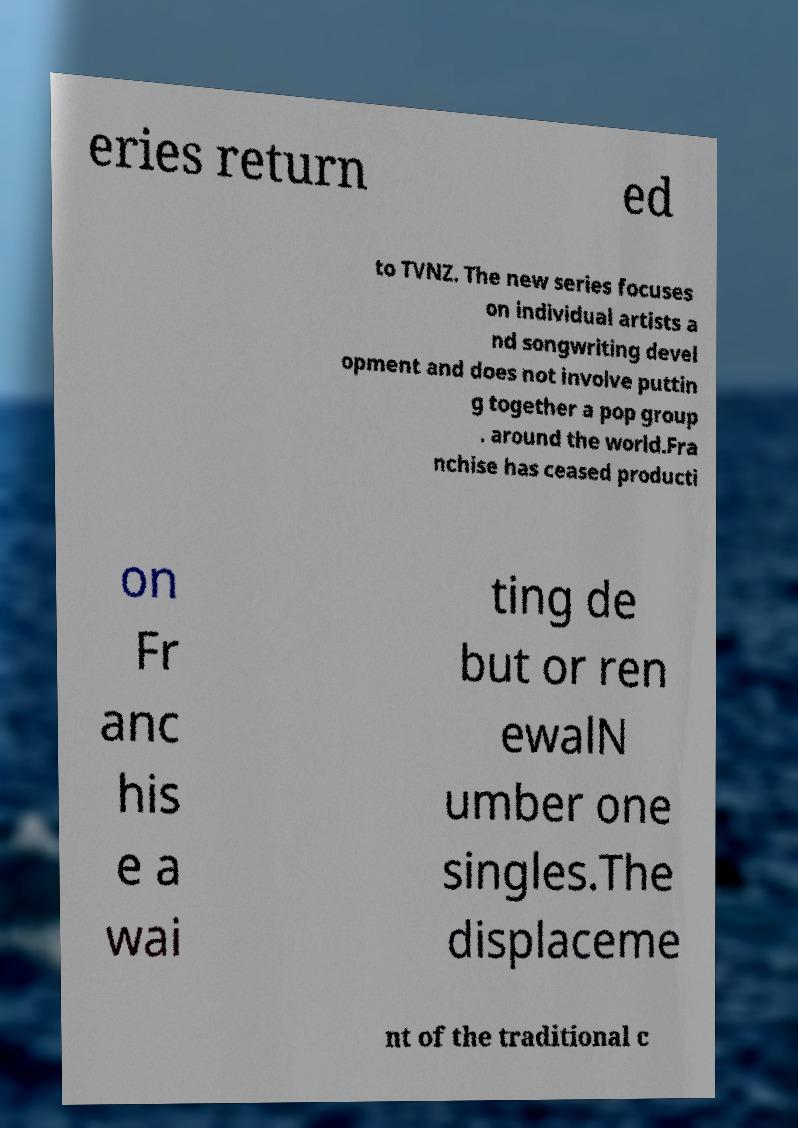Please identify and transcribe the text found in this image. eries return ed to TVNZ. The new series focuses on individual artists a nd songwriting devel opment and does not involve puttin g together a pop group . around the world.Fra nchise has ceased producti on Fr anc his e a wai ting de but or ren ewalN umber one singles.The displaceme nt of the traditional c 